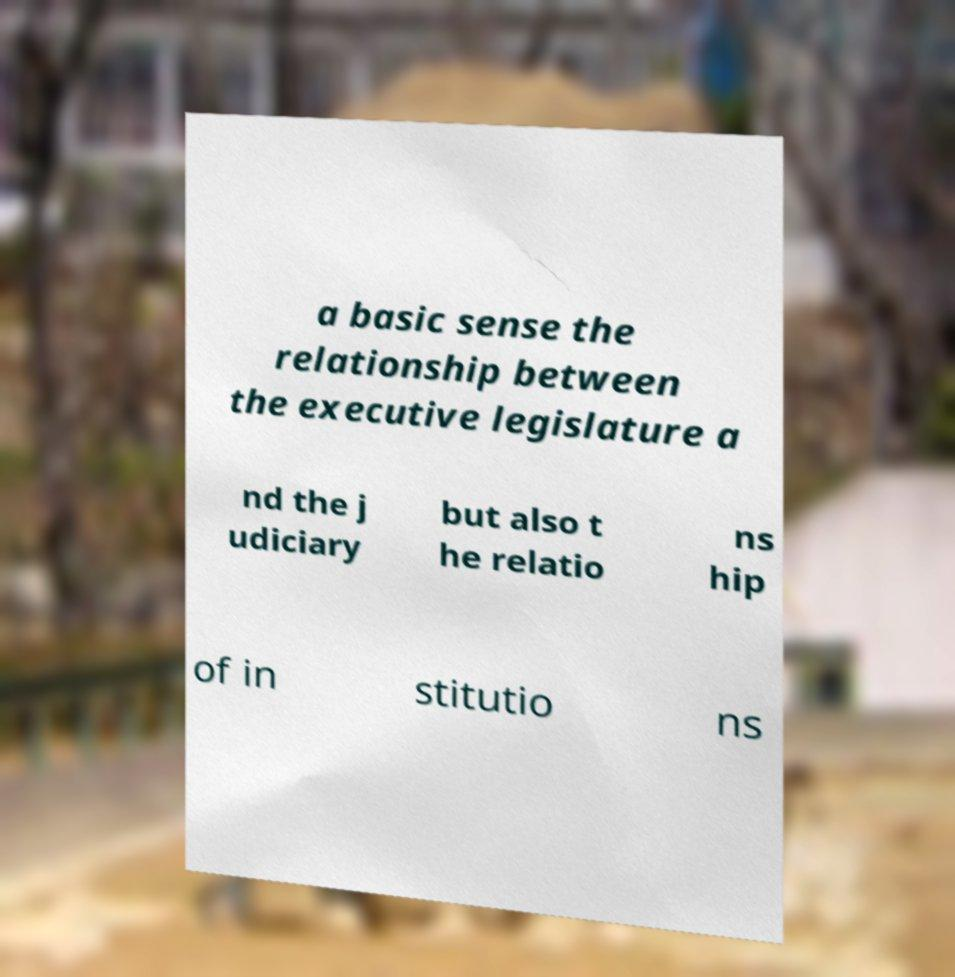What messages or text are displayed in this image? I need them in a readable, typed format. a basic sense the relationship between the executive legislature a nd the j udiciary but also t he relatio ns hip of in stitutio ns 